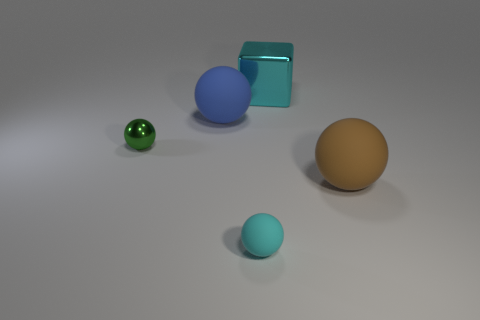Add 3 large brown matte balls. How many objects exist? 8 Subtract all balls. How many objects are left? 1 Add 3 small things. How many small things are left? 5 Add 5 big green objects. How many big green objects exist? 5 Subtract 0 yellow blocks. How many objects are left? 5 Subtract all big shiny cubes. Subtract all spheres. How many objects are left? 0 